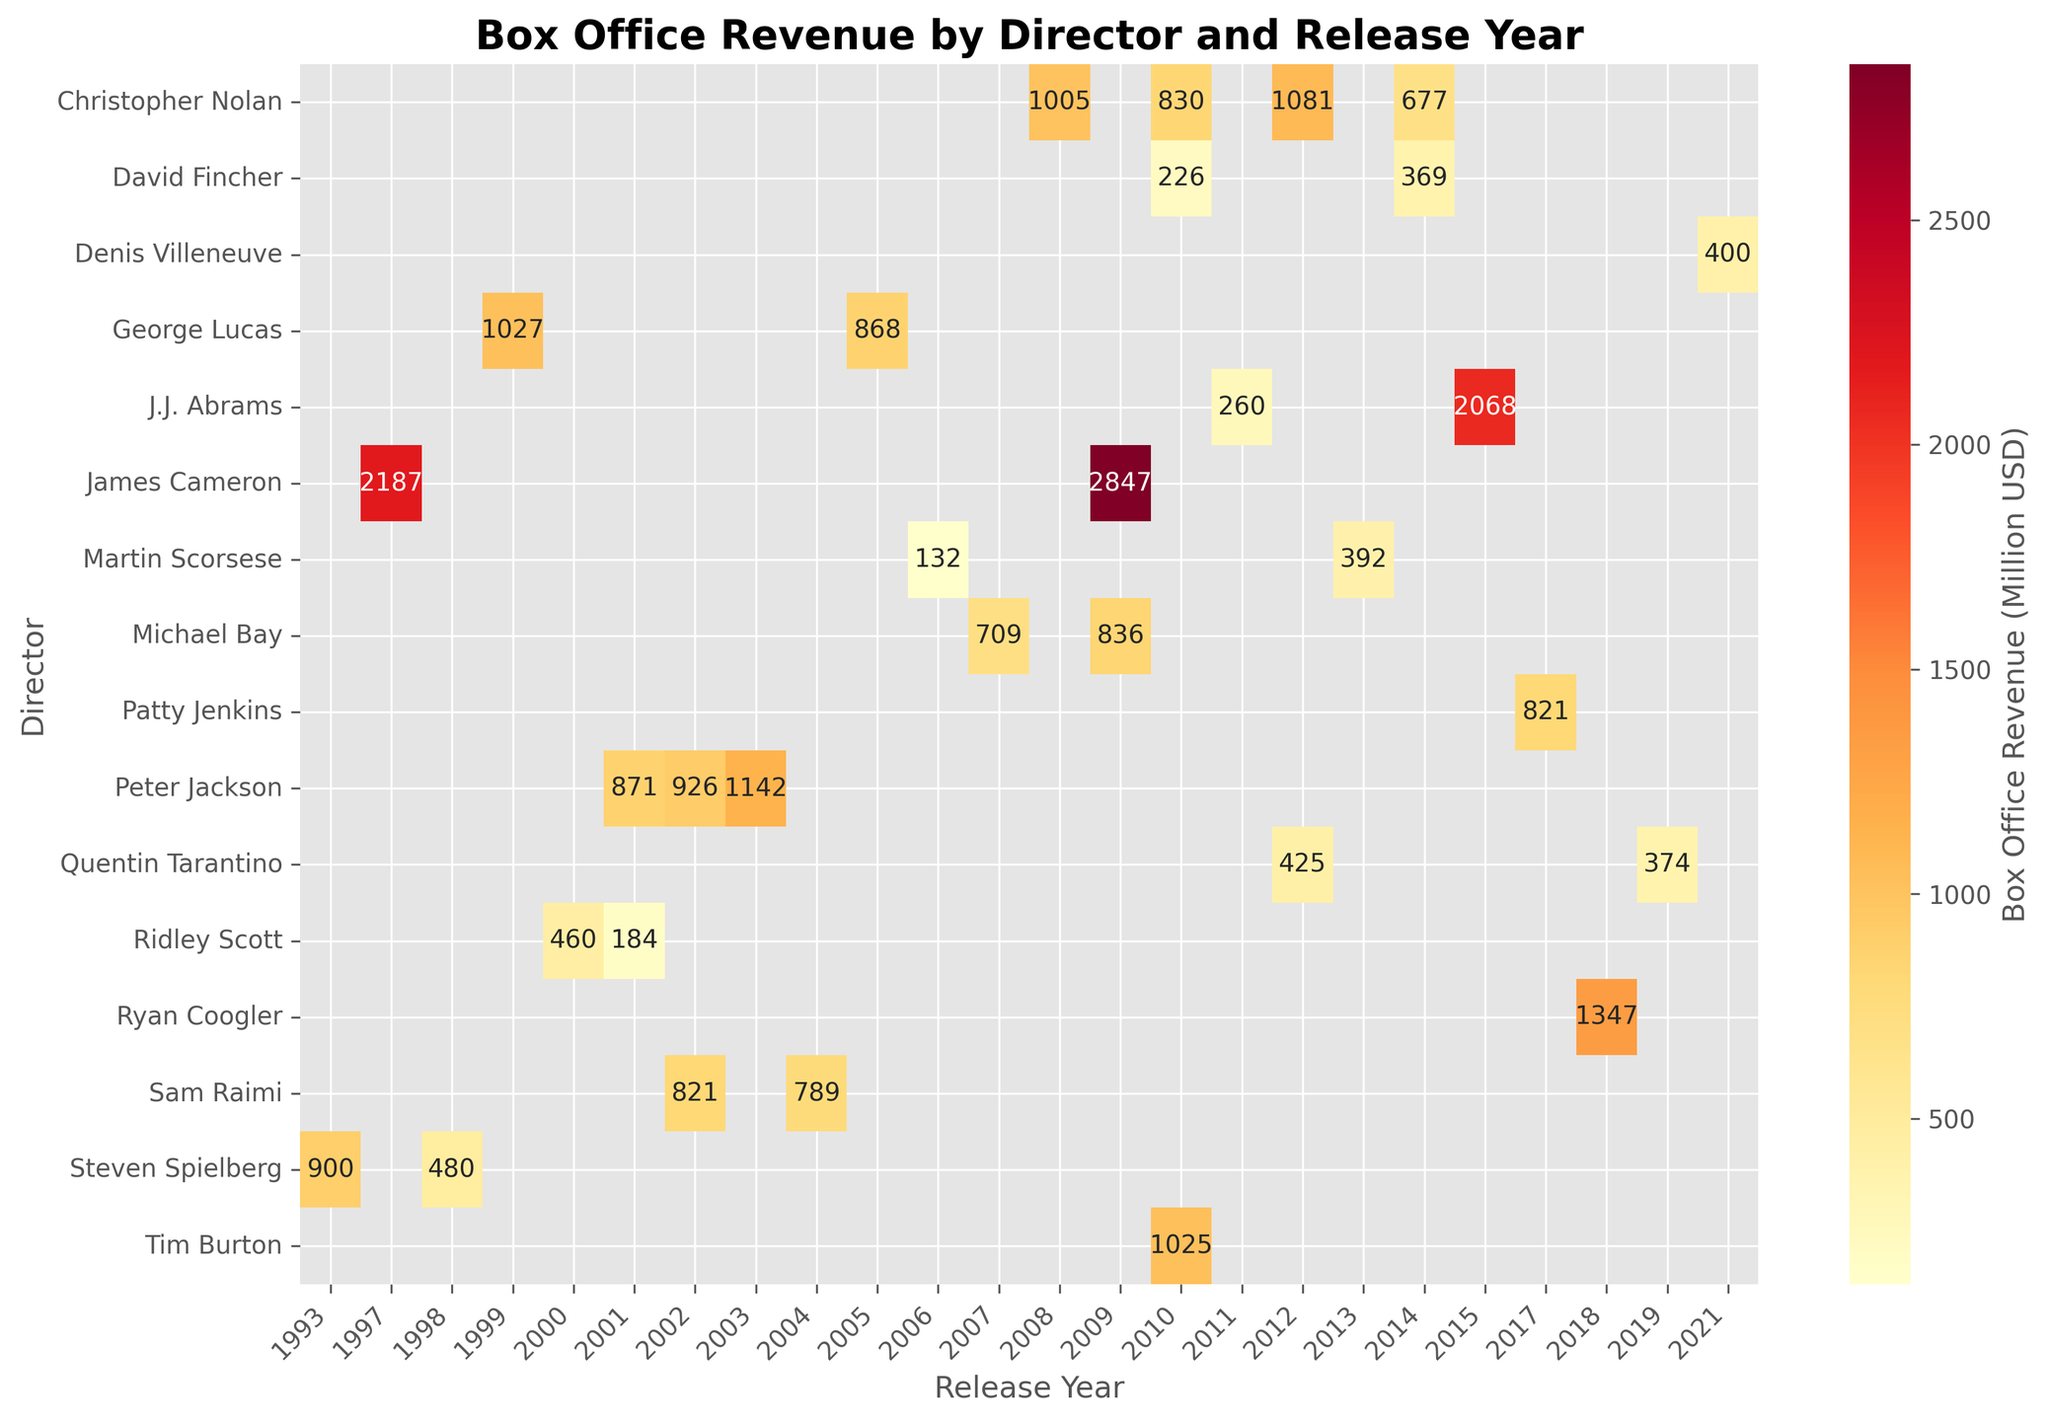What is the title of the heatmap? The title is located at the top of the figure and provides an overview of what is being displayed. It helps the observer understand the context of the data.
Answer: Box Office Revenue by Director and Release Year Which director has the highest box office revenue in this heatmap? To find the highest box office revenue, look for the cell with the darkest color or the highest annotated value. The director associated with this cell is the one with the highest revenue.
Answer: James Cameron How much box office revenue did Steven Spielberg's movies generate in 1993? Locate the cell at the intersection of Steven Spielberg and 1993 in the heatmap. The value in this cell represents the box office revenue for that year.
Answer: 900 million USD What is the difference in box office revenue between J.J. Abrams' 2015 film and his 2011 film? Find the revenues for J.J. Abrams' 2015 and 2011 films in their respective cells. Subtract the revenue of 2011 from that of 2015 to get the difference.
Answer: 1808 million USD Which director had movies with box office revenue over 1000 million USD in multiple years? Look for directors who have cells with values over 1000 in more than one year. Identify those directors and the specific years from the heatmap.
Answer: Christopher Nolan and James Cameron What pattern can you observe about Peter Jackson's box office revenue over the years? Identify the cells corresponding to Peter Jackson and observe the values from 2001 to 2003. Note any trends or changes in the revenue over these years.
Answer: Increasing trend from 2001 (871) to 2003 (1142) Which year did Christopher Nolan release a film with the highest box office revenue? Look for the highest value within the rows associated with Christopher Nolan. The year corresponding to this value is the year with the highest revenue.
Answer: 2012 What's the average box office revenue for Quentin Tarantino's movies shown in this heatmap? Add the revenues of Quentin Tarantino's movies and divide by the number of entries for him. (425 + 374) / 2 = 399.5
Answer: 399.5 million USD Who directed the movie with the lowest box office revenue in the heatmap? Identify the cell with the lowest annotated value and find the director associated with that value.
Answer: Martin Scorsese Which director's movies didn't reach 500 million USD revenue in any year? Look for directors whose cells all contain values below 500 million USD. Identify such directors by examining each cell corresponding to them.
Answer: David Fincher and Tim Burton 